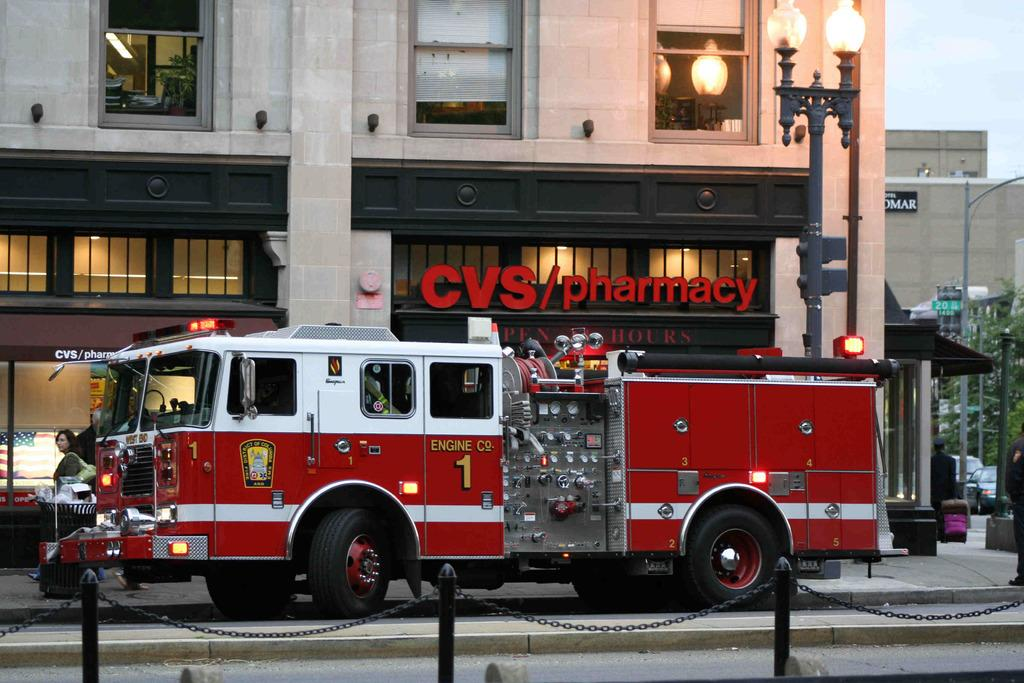How many people are in the image? There are people in the image, but the exact number is not specified. What else can be seen in the image besides people? There are vehicles, a road, poles, lights, chains, a building with windows, text on the building, boards, and posters in the image. Can you describe the building in the image? The building has windows and text on it. What is visible in the sky in the image? The sky is visible in the image, but the weather or time of day is not specified. How many passengers are wearing masks in the image? There is no information about passengers or masks in the image, so this question cannot be answered. What type of hat is the person wearing in the image? There is no person wearing a hat in the image, so this question cannot be answered. 